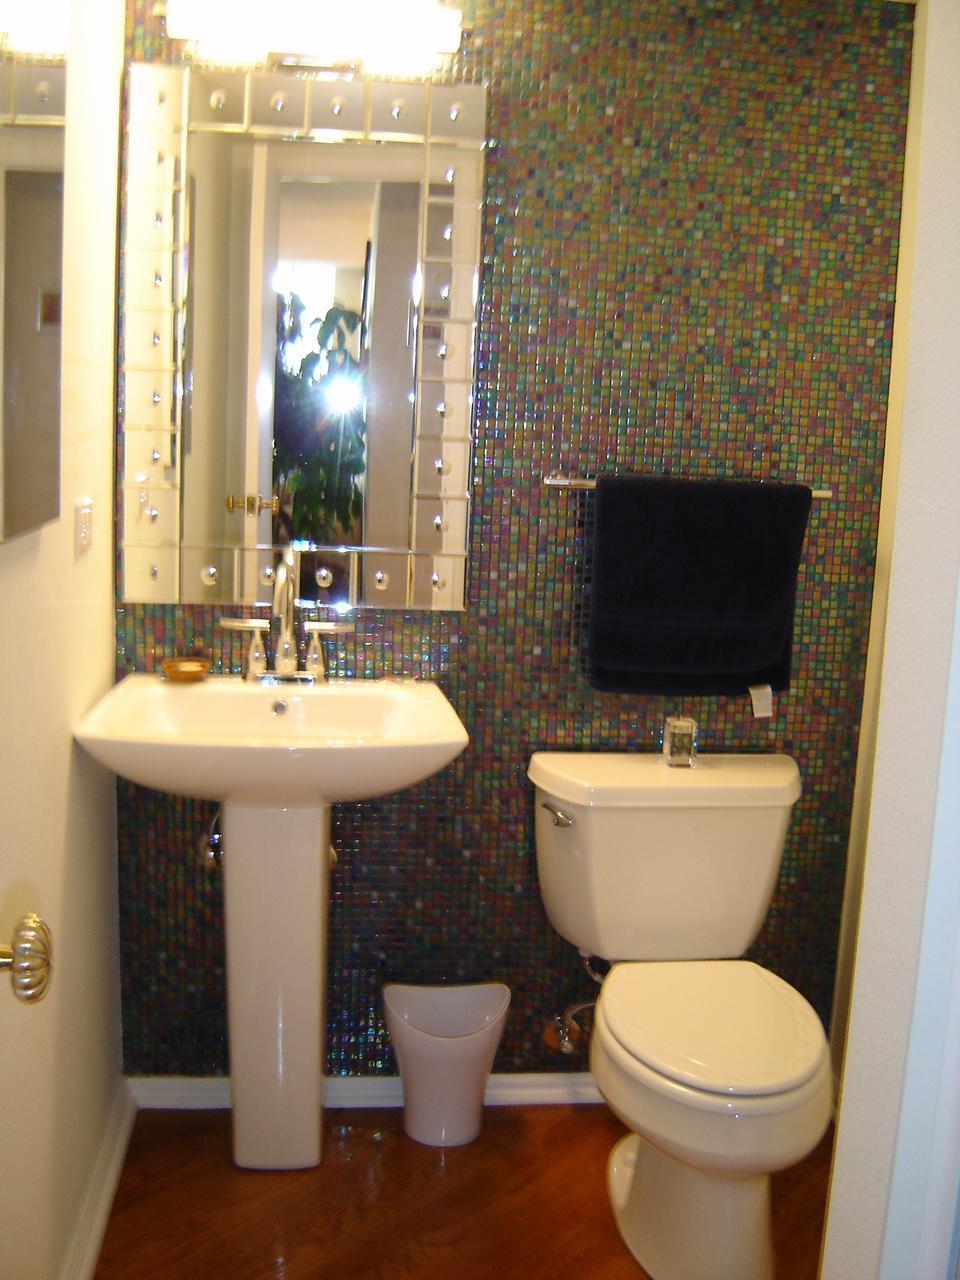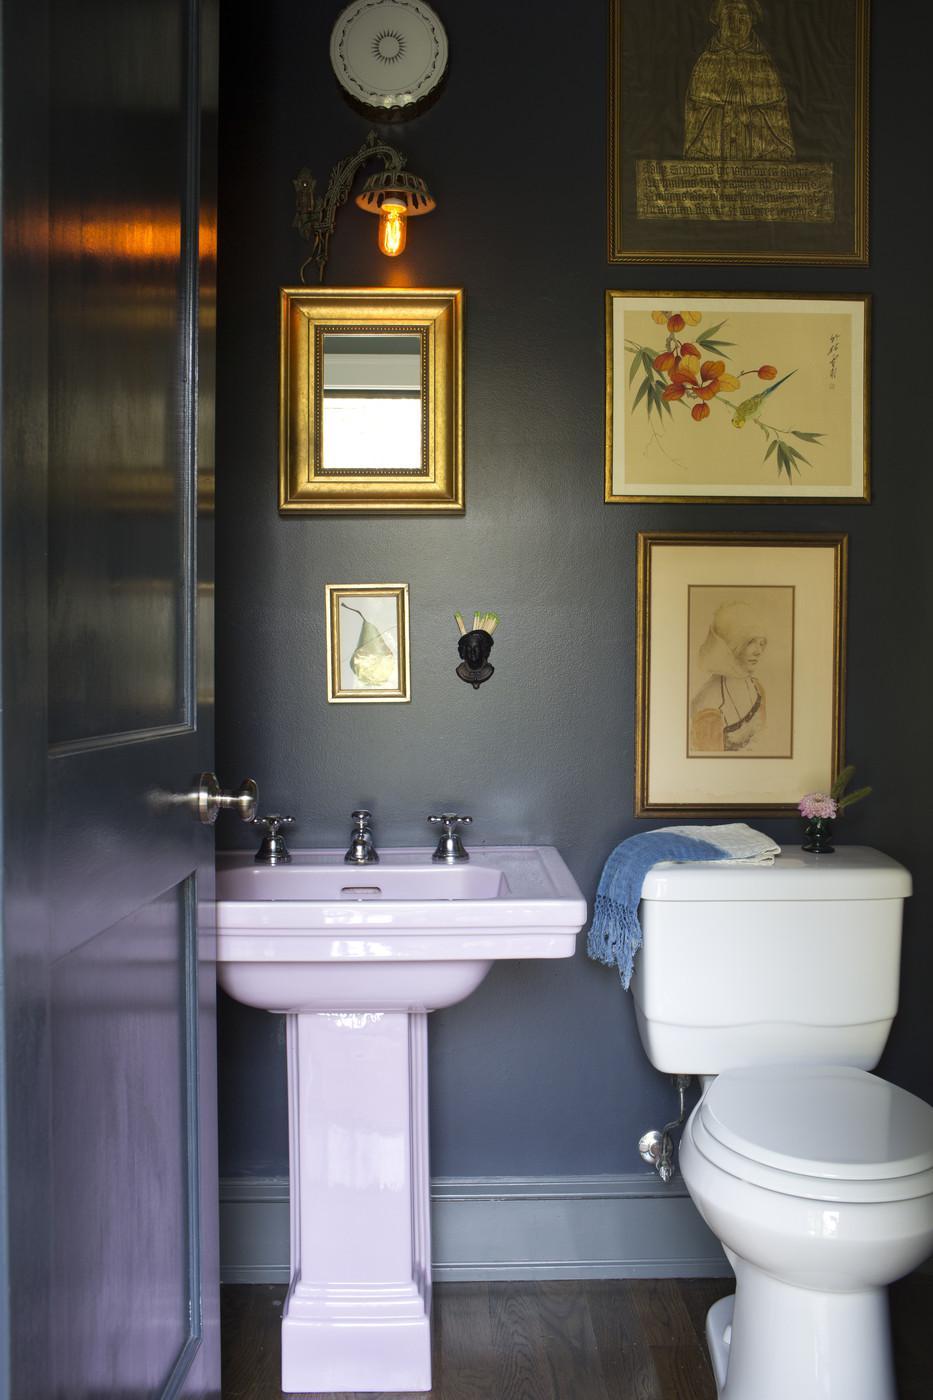The first image is the image on the left, the second image is the image on the right. Given the left and right images, does the statement "a toilet can be seen" hold true? Answer yes or no. Yes. The first image is the image on the left, the second image is the image on the right. For the images displayed, is the sentence "All of the bathrooms have double sinks." factually correct? Answer yes or no. No. 